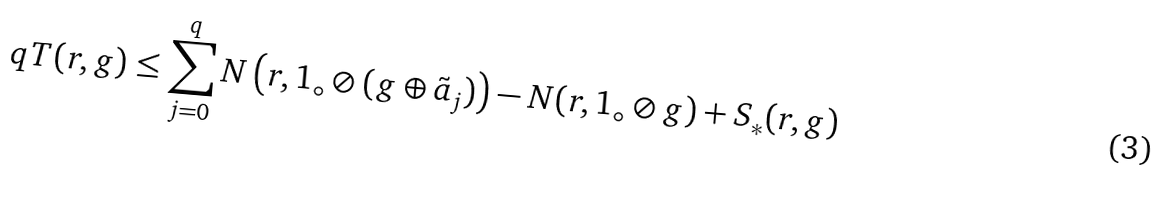<formula> <loc_0><loc_0><loc_500><loc_500>q T ( r , g ) \leq \sum _ { j = 0 } ^ { q } N \left ( r , 1 _ { \circ } \oslash ( g \oplus \tilde { a } _ { j } ) \right ) - N ( r , 1 _ { \circ } \oslash g ) + S _ { \ast } ( r , g )</formula> 